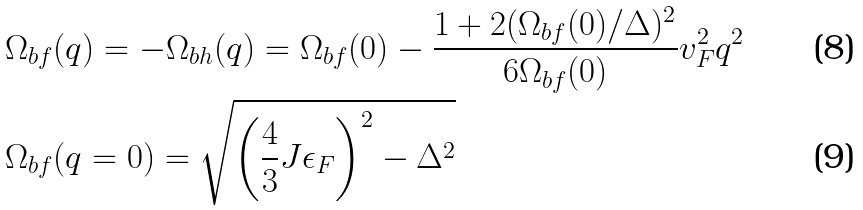<formula> <loc_0><loc_0><loc_500><loc_500>& \Omega _ { b f } ( q ) = - \Omega _ { b h } ( q ) = \Omega _ { b f } ( 0 ) - \frac { 1 + 2 ( \Omega _ { b f } ( 0 ) / \Delta ) ^ { 2 } } { 6 \Omega _ { b f } ( 0 ) } v _ { F } ^ { 2 } q ^ { 2 } \\ & \Omega _ { b f } ( q = 0 ) = \sqrt { \left ( \frac { 4 } { 3 } J \epsilon _ { F } \right ) ^ { 2 } - \Delta ^ { 2 } }</formula> 